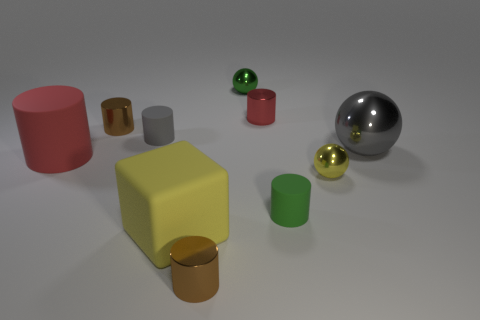Is the tiny gray rubber object the same shape as the large red rubber thing?
Ensure brevity in your answer.  Yes. There is a small metallic cylinder that is to the left of the yellow object that is to the left of the yellow metal sphere; are there any tiny brown objects that are on the right side of it?
Your answer should be very brief. Yes. How many other objects are there of the same color as the block?
Give a very brief answer. 1. There is a metal cylinder in front of the large gray object; is it the same size as the red cylinder that is to the left of the cube?
Keep it short and to the point. No. Are there the same number of large blocks that are in front of the large yellow cube and rubber cylinders that are on the right side of the green metal ball?
Offer a very short reply. No. Is the size of the red metal cylinder the same as the green thing that is behind the large red cylinder?
Offer a very short reply. Yes. There is a tiny gray cylinder that is on the left side of the yellow object on the left side of the green metallic object; what is its material?
Your answer should be compact. Rubber. Are there an equal number of big matte objects to the right of the large red matte object and tiny gray rubber cylinders?
Give a very brief answer. Yes. There is a matte cylinder that is in front of the big ball and on the left side of the cube; how big is it?
Provide a succinct answer. Large. What color is the matte cylinder that is to the right of the small brown cylinder that is right of the large rubber cube?
Make the answer very short. Green. 